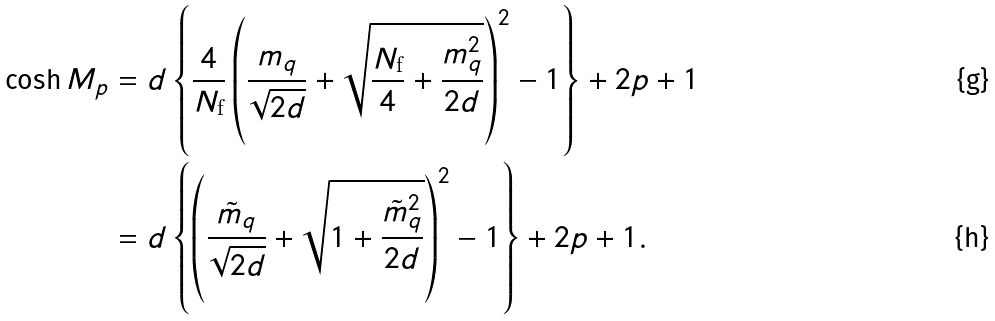<formula> <loc_0><loc_0><loc_500><loc_500>\cosh M _ { p } & = d \left \{ \frac { 4 } { N _ { \text {f} } } \left ( \frac { m _ { q } } { \sqrt { 2 d } } + \sqrt { \frac { N _ { \text {f} } } { 4 } + \frac { m _ { q } ^ { 2 } } { 2 d } } \right ) ^ { 2 } - 1 \right \} + 2 p + 1 \\ & = d \left \{ \left ( \frac { \tilde { m } _ { q } } { \sqrt { 2 d } } + \sqrt { 1 + \frac { \tilde { m } _ { q } ^ { 2 } } { 2 d } } \right ) ^ { 2 } - 1 \right \} + 2 p + 1 .</formula> 